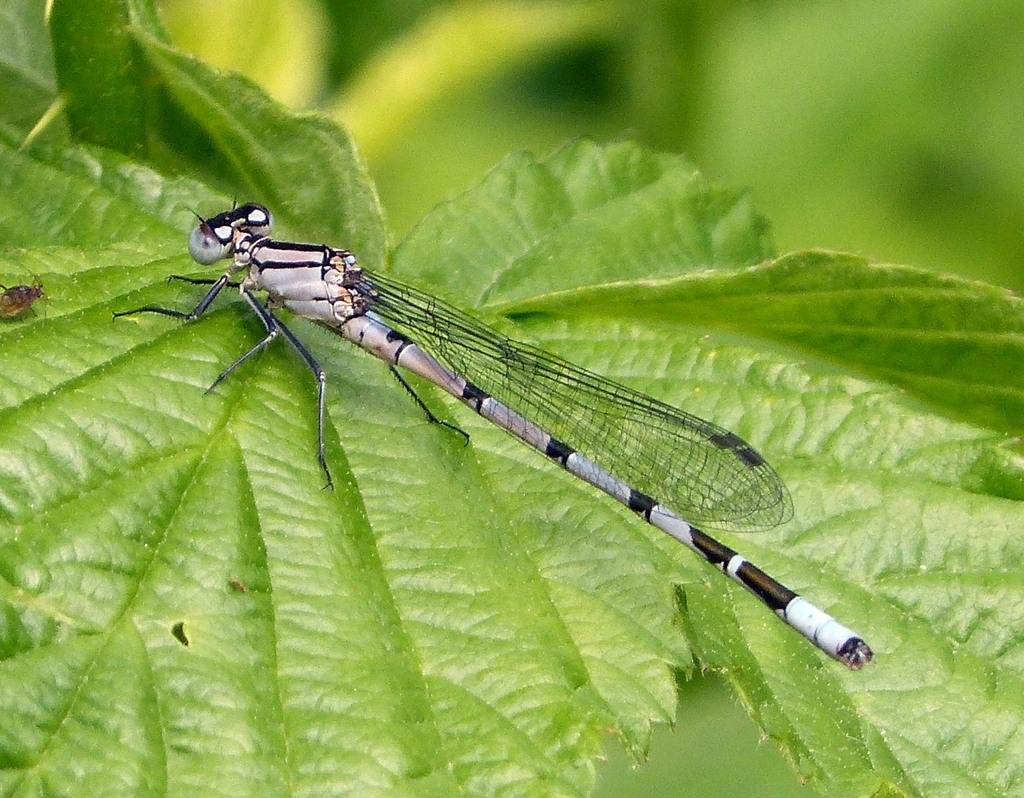What is the main subject of the picture? The main subject of the picture is a coenagrion. Where is the coenagrion located in the image? The coenagrion is present on a leaf. Can you describe the background of the image? The background of the image is blurry. What flavor of secretary can be seen in the image? There is no secretary present in the image, and therefore no flavor can be associated with it. 